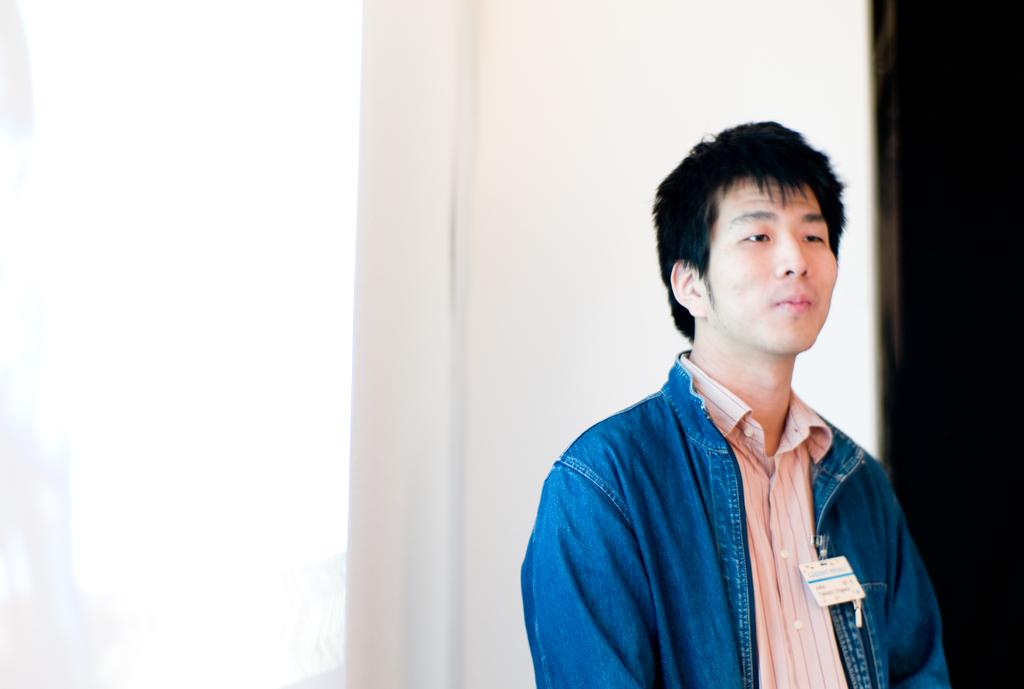Who is present in the image? There is a man in the picture. What is the man doing in the image? The man is standing in front. What type of clothing is the man wearing? The man is wearing a jacket and a shirt. What is the color scheme of the background in the image? The background of the image is white and black in color. What type of voice can be heard coming from the man in the image? There is no indication of sound or voice in the image, as it is a still photograph. 